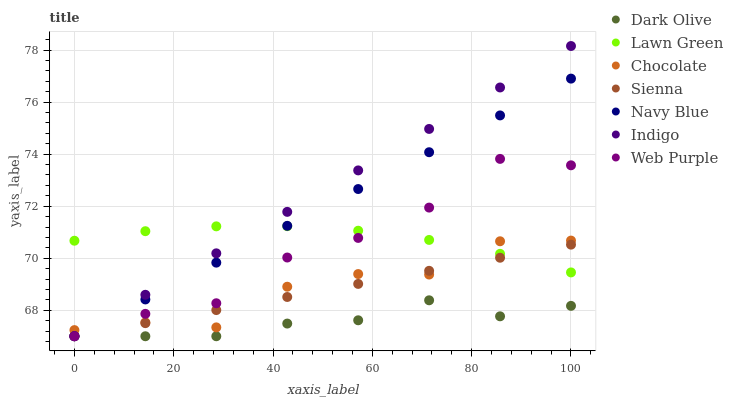Does Dark Olive have the minimum area under the curve?
Answer yes or no. Yes. Does Indigo have the maximum area under the curve?
Answer yes or no. Yes. Does Navy Blue have the minimum area under the curve?
Answer yes or no. No. Does Navy Blue have the maximum area under the curve?
Answer yes or no. No. Is Sienna the smoothest?
Answer yes or no. Yes. Is Chocolate the roughest?
Answer yes or no. Yes. Is Indigo the smoothest?
Answer yes or no. No. Is Indigo the roughest?
Answer yes or no. No. Does Indigo have the lowest value?
Answer yes or no. Yes. Does Chocolate have the lowest value?
Answer yes or no. No. Does Indigo have the highest value?
Answer yes or no. Yes. Does Navy Blue have the highest value?
Answer yes or no. No. Is Dark Olive less than Chocolate?
Answer yes or no. Yes. Is Chocolate greater than Dark Olive?
Answer yes or no. Yes. Does Sienna intersect Chocolate?
Answer yes or no. Yes. Is Sienna less than Chocolate?
Answer yes or no. No. Is Sienna greater than Chocolate?
Answer yes or no. No. Does Dark Olive intersect Chocolate?
Answer yes or no. No. 